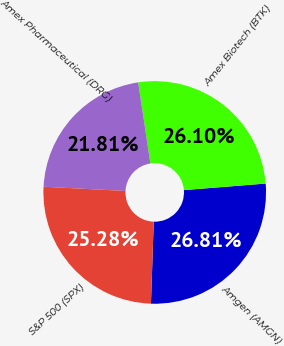<chart> <loc_0><loc_0><loc_500><loc_500><pie_chart><fcel>Amgen (AMGN)<fcel>Amex Biotech (BTK)<fcel>Amex Pharmaceutical (DRG)<fcel>S&P 500 (SPX)<nl><fcel>26.81%<fcel>26.1%<fcel>21.81%<fcel>25.28%<nl></chart> 